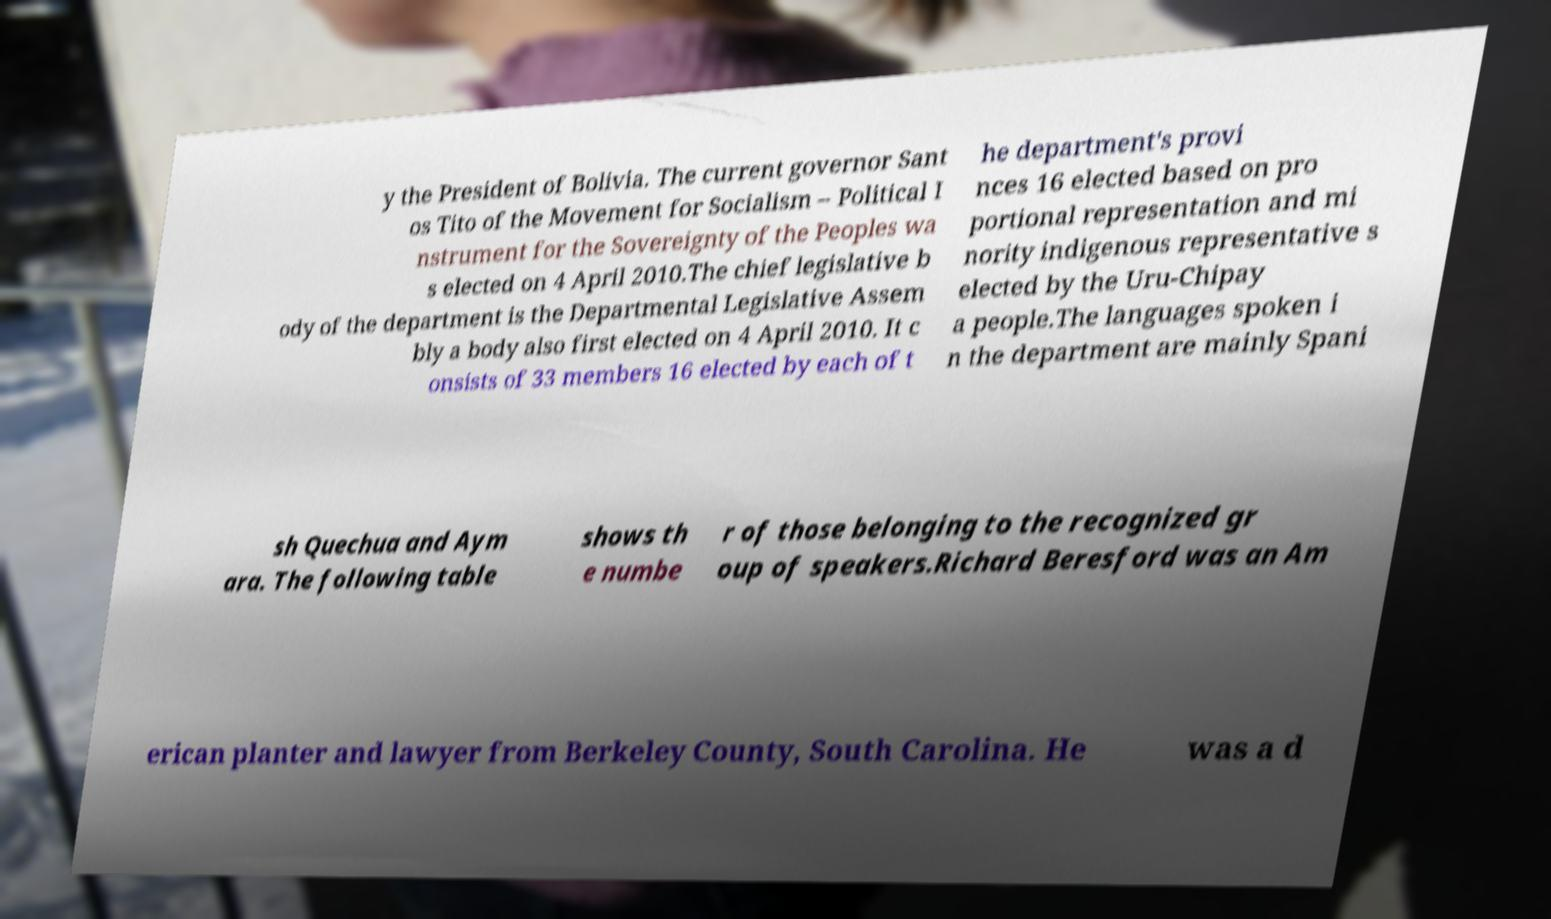I need the written content from this picture converted into text. Can you do that? y the President of Bolivia. The current governor Sant os Tito of the Movement for Socialism – Political I nstrument for the Sovereignty of the Peoples wa s elected on 4 April 2010.The chief legislative b ody of the department is the Departmental Legislative Assem bly a body also first elected on 4 April 2010. It c onsists of 33 members 16 elected by each of t he department's provi nces 16 elected based on pro portional representation and mi nority indigenous representative s elected by the Uru-Chipay a people.The languages spoken i n the department are mainly Spani sh Quechua and Aym ara. The following table shows th e numbe r of those belonging to the recognized gr oup of speakers.Richard Beresford was an Am erican planter and lawyer from Berkeley County, South Carolina. He was a d 